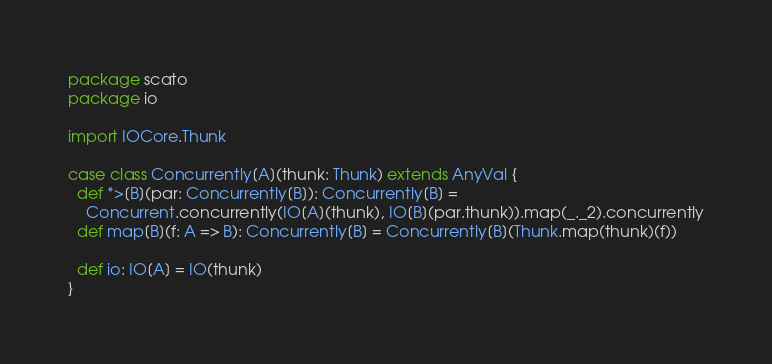<code> <loc_0><loc_0><loc_500><loc_500><_Scala_>package scato
package io

import IOCore.Thunk

case class Concurrently[A](thunk: Thunk) extends AnyVal {
  def *>[B](par: Concurrently[B]): Concurrently[B] =
    Concurrent.concurrently(IO[A](thunk), IO[B](par.thunk)).map(_._2).concurrently
  def map[B](f: A => B): Concurrently[B] = Concurrently[B](Thunk.map(thunk)(f))

  def io: IO[A] = IO(thunk)
}

</code> 